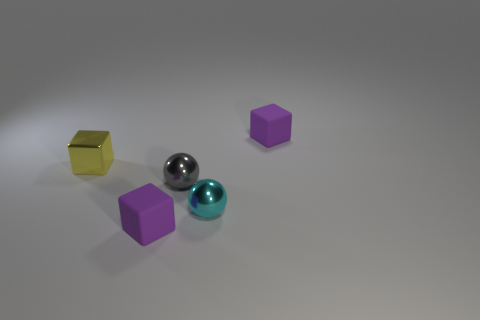If this image was part of a sequence, what might happen next? If this image were part of a sequence, we might imagine that the next scene could involve a change in the positions of the objects, perhaps suggesting motion or interaction. The spheres could roll away, altering the balance of the composition, or another object might be introduced to the scene, creating a new focus for the viewer's attention. 